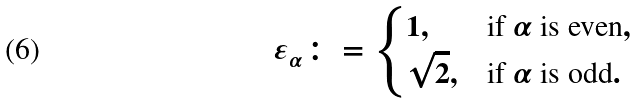Convert formula to latex. <formula><loc_0><loc_0><loc_500><loc_500>\varepsilon _ { \alpha } \colon = \begin{cases} 1 , & \text {if } \alpha \text { is even} , \\ \sqrt { 2 } , & \text {if } \alpha \text { is odd} . \end{cases}</formula> 